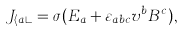Convert formula to latex. <formula><loc_0><loc_0><loc_500><loc_500>J _ { \langle a \rangle } = \sigma ( E _ { a } + \varepsilon _ { a b c } v ^ { b } B ^ { c } ) ,</formula> 